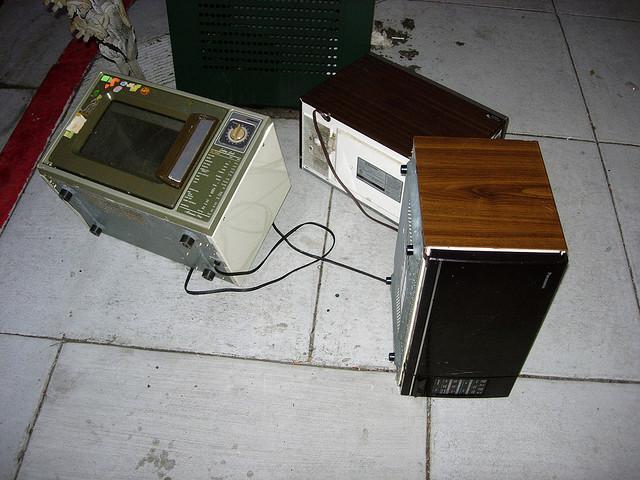How many microwaves are in the picture?
Give a very brief answer. 3. 